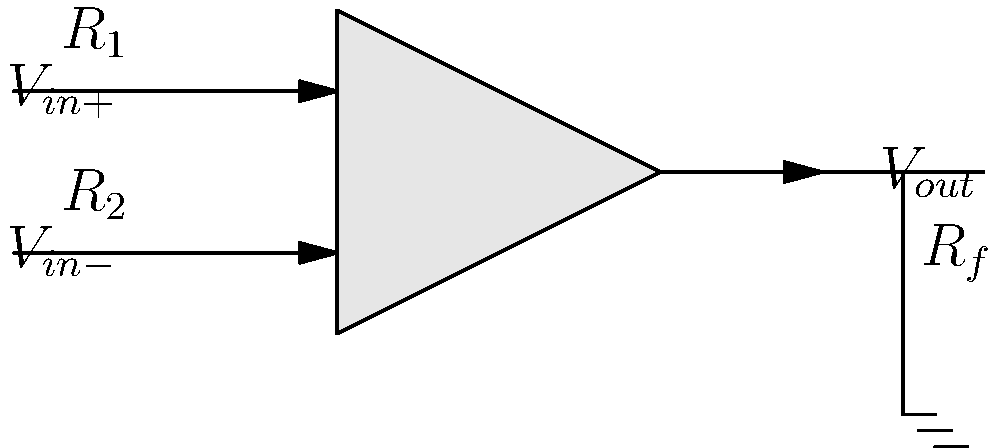In the given operational amplifier circuit schematic, what is the expression for the output voltage $V_{out}$ in terms of the input voltages $V_{in+}$ and $V_{in-}$ and the resistances $R_1$, $R_2$, and $R_f$, assuming the op-amp is ideal? To find the expression for $V_{out}$, we'll follow these steps:

1. Recall that for an ideal op-amp, the voltage difference between the inverting and non-inverting inputs is zero: $V_{in+} = V_{in-}$

2. The current through $R_1$ is: $I_1 = \frac{V_{in+} - V_{in-}}{R_1}$

3. The current through $R_2$ is: $I_2 = \frac{V_{in-} - V_{out}}{R_2}$

4. Due to the virtual ground concept, the inverting input draws no current, so $I_1 = I_2$

5. Equating these currents:
   $\frac{V_{in+} - V_{in-}}{R_1} = \frac{V_{in-} - V_{out}}{R_2}$

6. Rearranging the equation:
   $V_{out} = V_{in-} - \frac{R_2}{R_1}(V_{in+} - V_{in-})$

7. Simplifying:
   $V_{out} = V_{in-} - \frac{R_2}{R_1}V_{in+} + \frac{R_2}{R_1}V_{in-}$
   $V_{out} = V_{in-}(1 + \frac{R_2}{R_1}) - \frac{R_2}{R_1}V_{in+}$

8. The feedback resistor $R_f$ is connected between the output and the inverting input, which means $R_f = R_2$ in this configuration.

Therefore, the final expression for $V_{out}$ is:
$V_{out} = V_{in-}(1 + \frac{R_f}{R_1}) - \frac{R_f}{R_1}V_{in+}$
Answer: $V_{out} = V_{in-}(1 + \frac{R_f}{R_1}) - \frac{R_f}{R_1}V_{in+}$ 